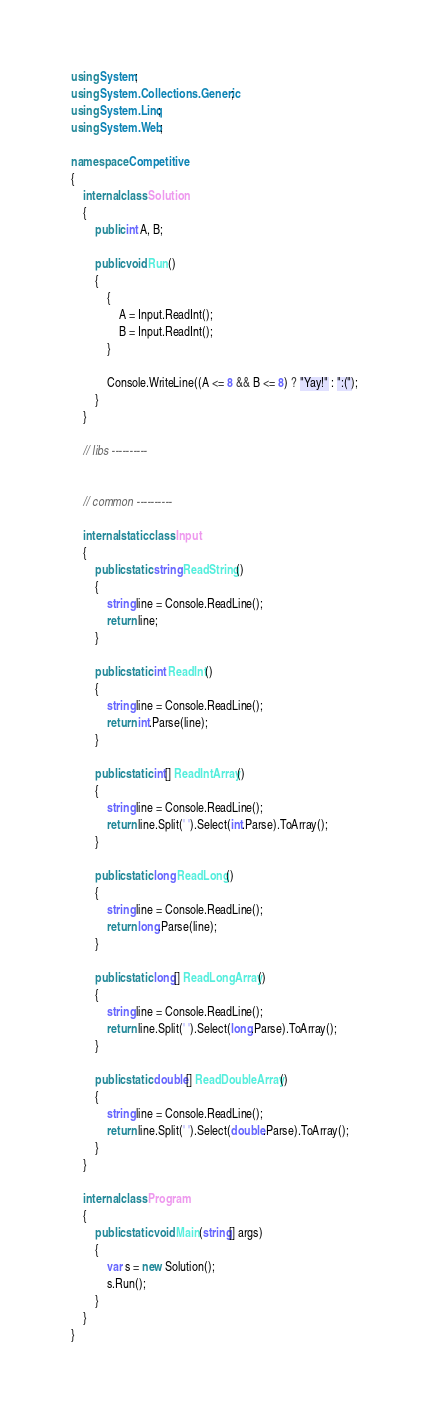Convert code to text. <code><loc_0><loc_0><loc_500><loc_500><_C#_>using System;
using System.Collections.Generic;
using System.Linq;
using System.Web;

namespace Competitive
{
    internal class Solution
    {
        public int A, B;

        public void Run()
        {
            {
                A = Input.ReadInt();
                B = Input.ReadInt();
            }

            Console.WriteLine((A <= 8 && B <= 8) ? "Yay!" : ":(");
        }
    }

    // libs ----------
    

    // common ----------

    internal static class Input
    {
        public static string ReadString()
        {
            string line = Console.ReadLine();
            return line;
        }

        public static int ReadInt()
        {
            string line = Console.ReadLine();
            return int.Parse(line);
        }

        public static int[] ReadIntArray()
        {
            string line = Console.ReadLine();
            return line.Split(' ').Select(int.Parse).ToArray();            
        }

        public static long ReadLong()
        {
            string line = Console.ReadLine();
            return long.Parse(line);
        }

        public static long[] ReadLongArray()
        {
            string line = Console.ReadLine();
            return line.Split(' ').Select(long.Parse).ToArray();
        }

        public static double[] ReadDoubleArray()
        {
            string line = Console.ReadLine();
            return line.Split(' ').Select(double.Parse).ToArray();
        }
    }
    
    internal class Program
    {
        public static void Main(string[] args)
        {
            var s = new Solution();
            s.Run();
        }
    }
}</code> 